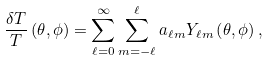Convert formula to latex. <formula><loc_0><loc_0><loc_500><loc_500>\frac { \delta T } { T } \left ( \theta , \phi \right ) = \sum _ { \ell = 0 } ^ { \infty } \sum _ { m = - \ell } ^ { \ell } a _ { \ell m } Y _ { \ell m } \left ( \theta , \phi \right ) ,</formula> 